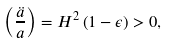Convert formula to latex. <formula><loc_0><loc_0><loc_500><loc_500>\left ( \frac { \ddot { a } } { a } \right ) = H ^ { 2 } \left ( 1 - \epsilon \right ) > 0 ,</formula> 